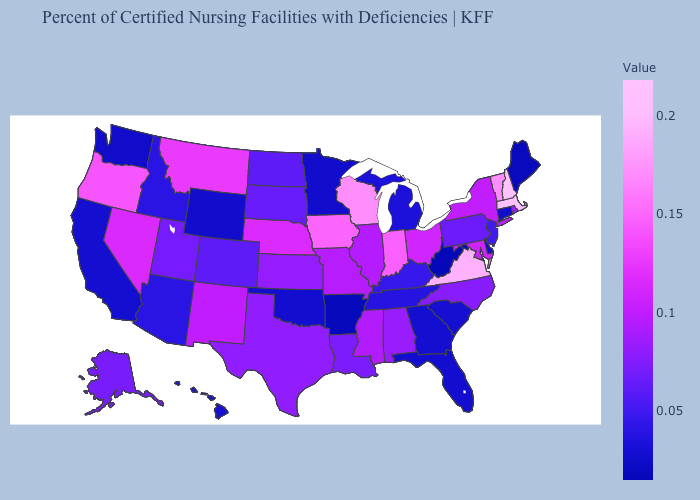Does the map have missing data?
Answer briefly. No. Does the map have missing data?
Concise answer only. No. Which states have the lowest value in the USA?
Quick response, please. West Virginia. Among the states that border Virginia , does Tennessee have the lowest value?
Keep it brief. No. 